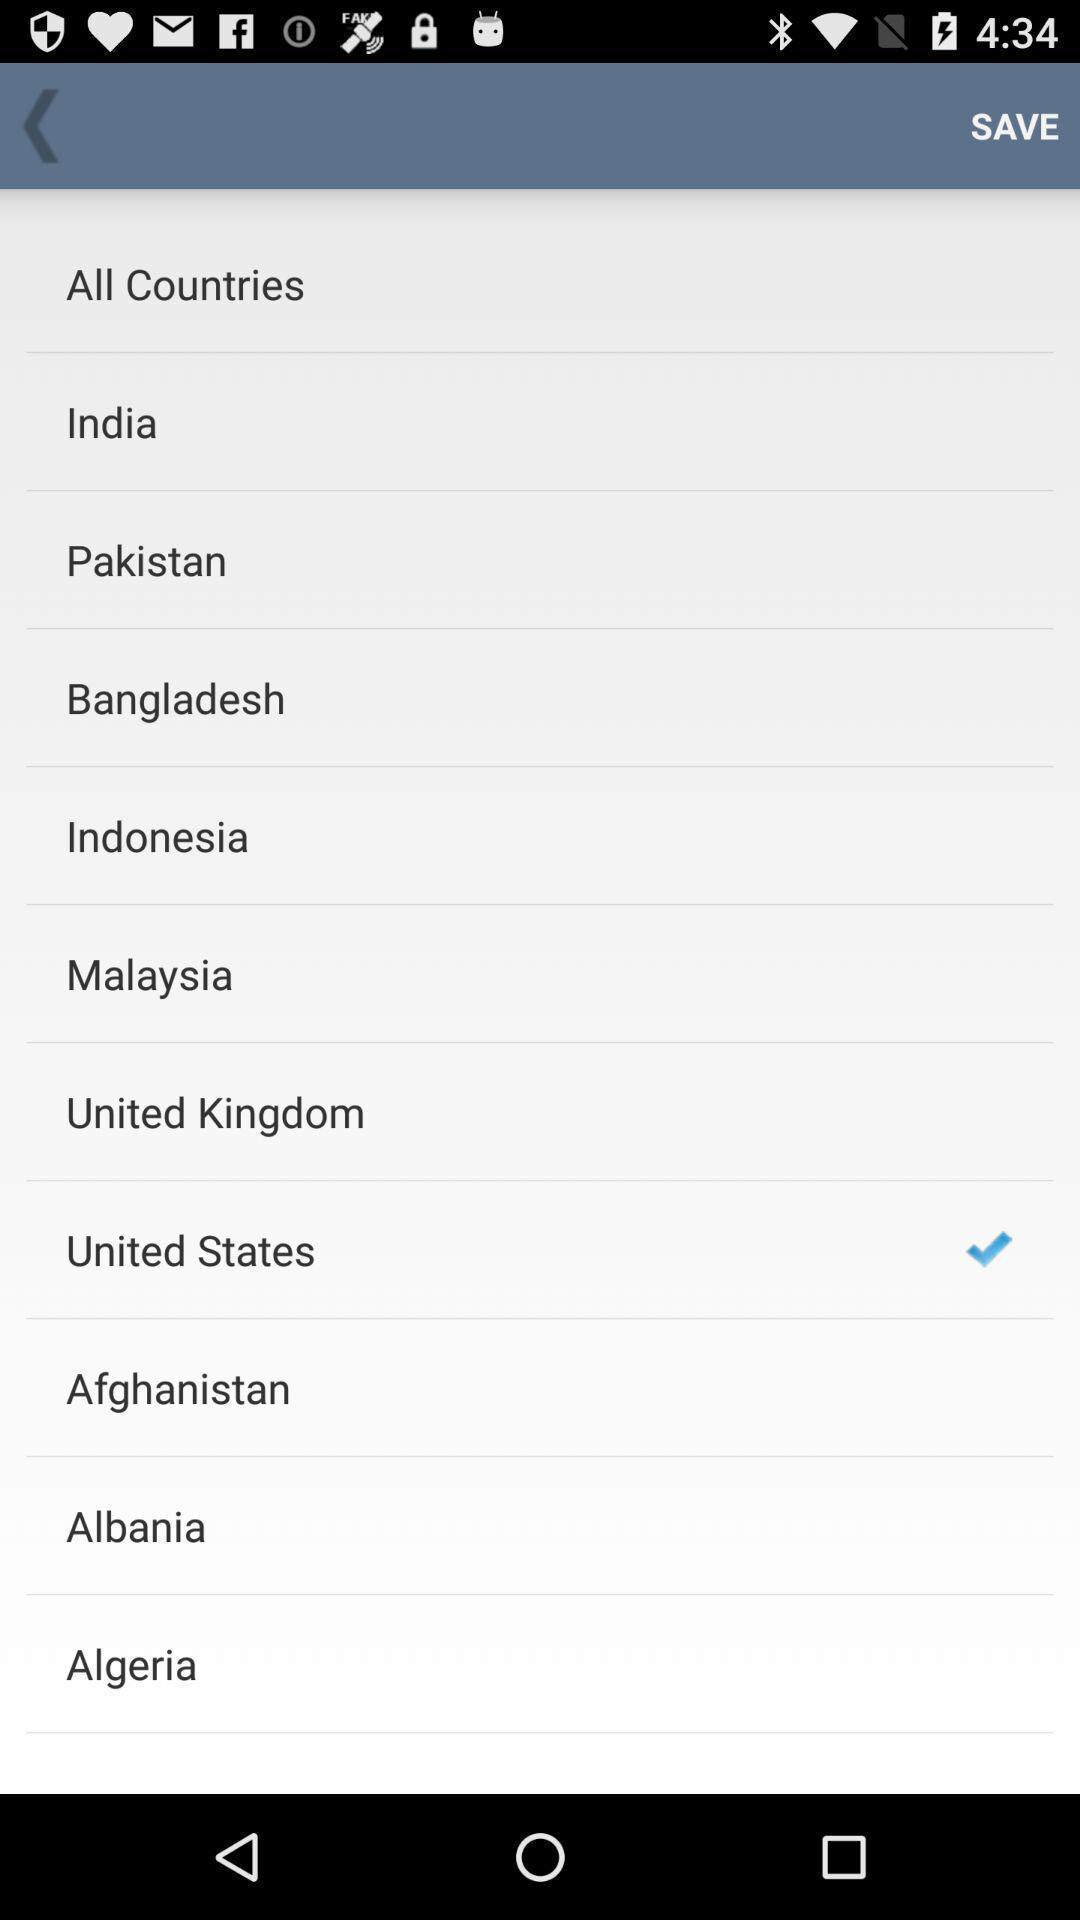Provide a detailed account of this screenshot. Screen shows list of options. 